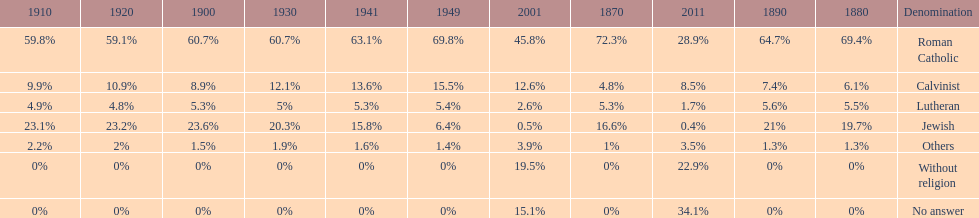Which denomination percentage increased the most after 1949? Without religion. Could you parse the entire table? {'header': ['1910', '1920', '1900', '1930', '1941', '1949', '2001', '1870', '2011', '1890', '1880', 'Denomination'], 'rows': [['59.8%', '59.1%', '60.7%', '60.7%', '63.1%', '69.8%', '45.8%', '72.3%', '28.9%', '64.7%', '69.4%', 'Roman Catholic'], ['9.9%', '10.9%', '8.9%', '12.1%', '13.6%', '15.5%', '12.6%', '4.8%', '8.5%', '7.4%', '6.1%', 'Calvinist'], ['4.9%', '4.8%', '5.3%', '5%', '5.3%', '5.4%', '2.6%', '5.3%', '1.7%', '5.6%', '5.5%', 'Lutheran'], ['23.1%', '23.2%', '23.6%', '20.3%', '15.8%', '6.4%', '0.5%', '16.6%', '0.4%', '21%', '19.7%', 'Jewish'], ['2.2%', '2%', '1.5%', '1.9%', '1.6%', '1.4%', '3.9%', '1%', '3.5%', '1.3%', '1.3%', 'Others'], ['0%', '0%', '0%', '0%', '0%', '0%', '19.5%', '0%', '22.9%', '0%', '0%', 'Without religion'], ['0%', '0%', '0%', '0%', '0%', '0%', '15.1%', '0%', '34.1%', '0%', '0%', 'No answer']]} 